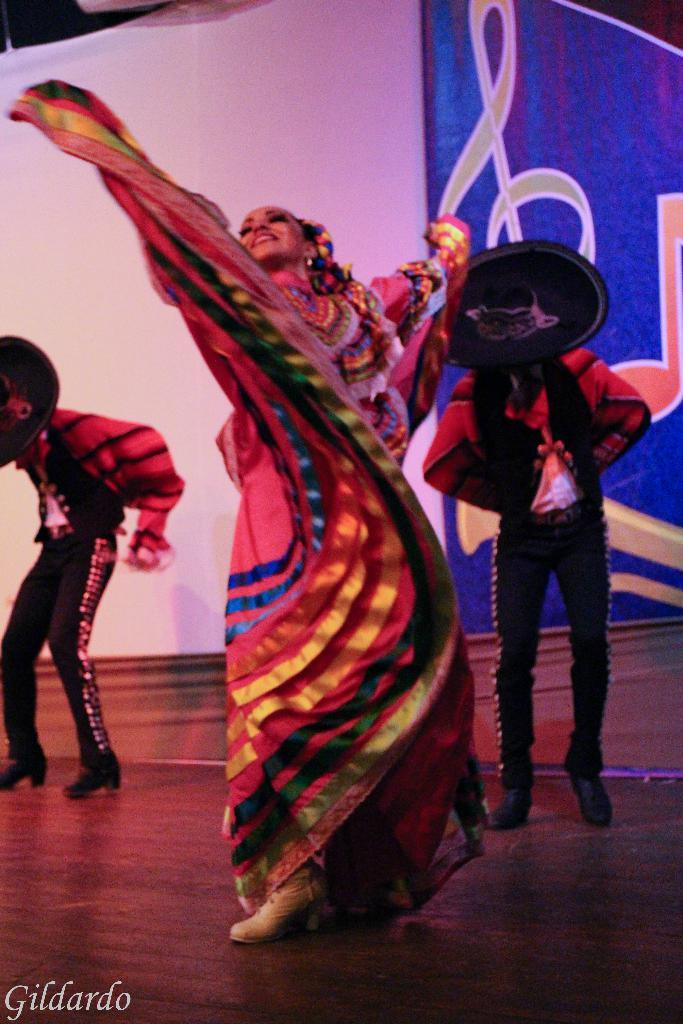What is happening on the stage in the image? There are people standing on the stage in the image. What are the people wearing? The people are wearing costumes. What can be seen behind the people on the stage? There is a curtain visible in the image. What is depicted on the curtain? The curtain has a picture on it. How many rabbits are sitting on the page in the image? There are no rabbits or pages present in the image. What type of lead is being used by the people on the stage? There is no indication of any lead being used by the people on the stage; they are wearing costumes. 